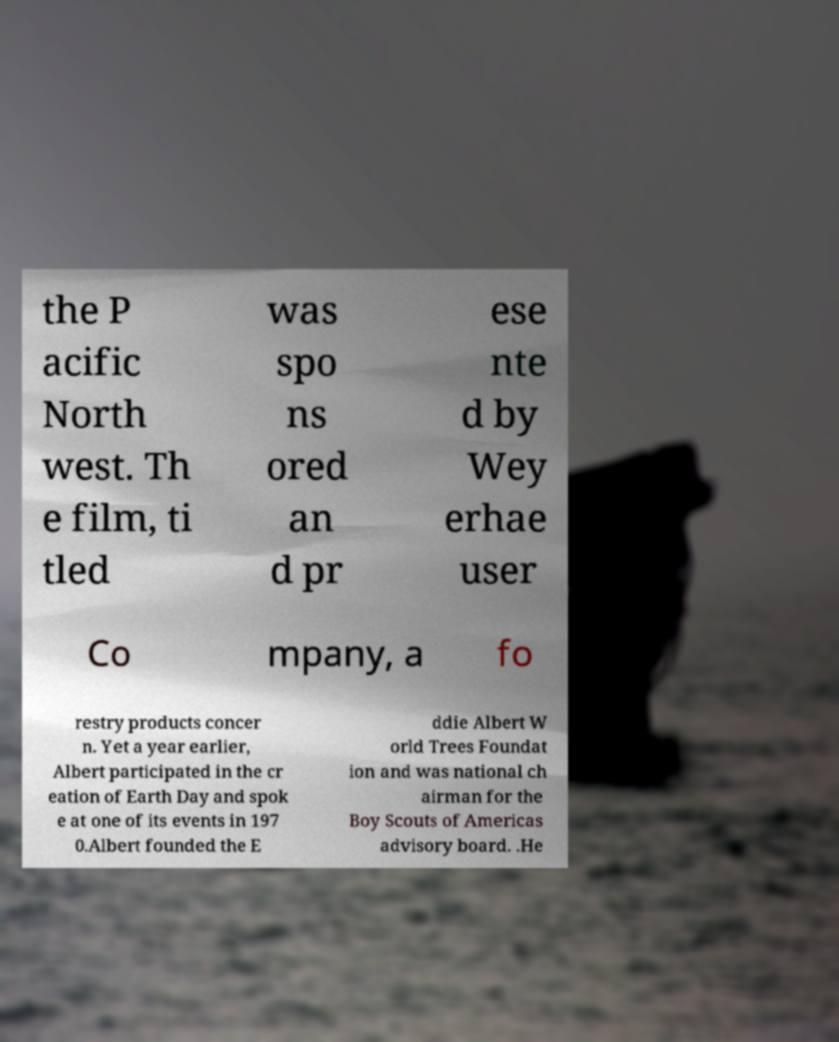Could you assist in decoding the text presented in this image and type it out clearly? the P acific North west. Th e film, ti tled was spo ns ored an d pr ese nte d by Wey erhae user Co mpany, a fo restry products concer n. Yet a year earlier, Albert participated in the cr eation of Earth Day and spok e at one of its events in 197 0.Albert founded the E ddie Albert W orld Trees Foundat ion and was national ch airman for the Boy Scouts of Americas advisory board. .He 